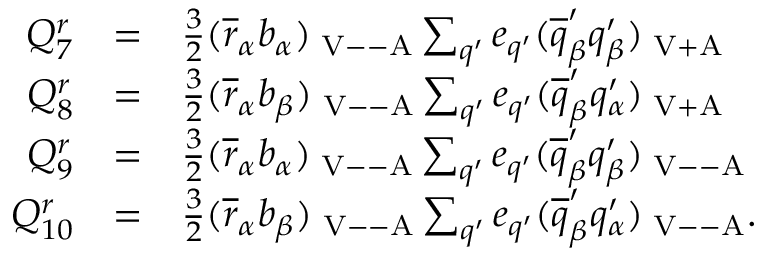Convert formula to latex. <formula><loc_0><loc_0><loc_500><loc_500>\begin{array} { r c l } { { Q _ { 7 } ^ { r } } } & { = } & { { \frac { 3 } { 2 } ( \overline { r } _ { \alpha } b _ { \alpha } ) _ { V - - A } \sum _ { q ^ { \prime } } e _ { q ^ { \prime } } ( \overline { q } _ { \beta } ^ { \prime } q _ { \beta } ^ { \prime } ) _ { V + A } } } \\ { { Q _ { 8 } ^ { r } } } & { = } & { { \frac { 3 } { 2 } ( \overline { r } _ { \alpha } b _ { \beta } ) _ { V - - A } \sum _ { q ^ { \prime } } e _ { q ^ { \prime } } ( \overline { q } _ { \beta } ^ { \prime } q _ { \alpha } ^ { \prime } ) _ { V + A } } } \\ { { Q _ { 9 } ^ { r } } } & { = } & { { \frac { 3 } { 2 } ( \overline { r } _ { \alpha } b _ { \alpha } ) _ { V - - A } \sum _ { q ^ { \prime } } e _ { q ^ { \prime } } ( \overline { q } _ { \beta } ^ { \prime } q _ { \beta } ^ { \prime } ) _ { V - - A } } } \\ { { Q _ { 1 0 } ^ { r } } } & { = } & { { \frac { 3 } { 2 } ( \overline { r } _ { \alpha } b _ { \beta } ) _ { V - - A } \sum _ { q ^ { \prime } } e _ { q ^ { \prime } } ( \overline { q } _ { \beta } ^ { \prime } q _ { \alpha } ^ { \prime } ) _ { V - - A } . } } \end{array}</formula> 